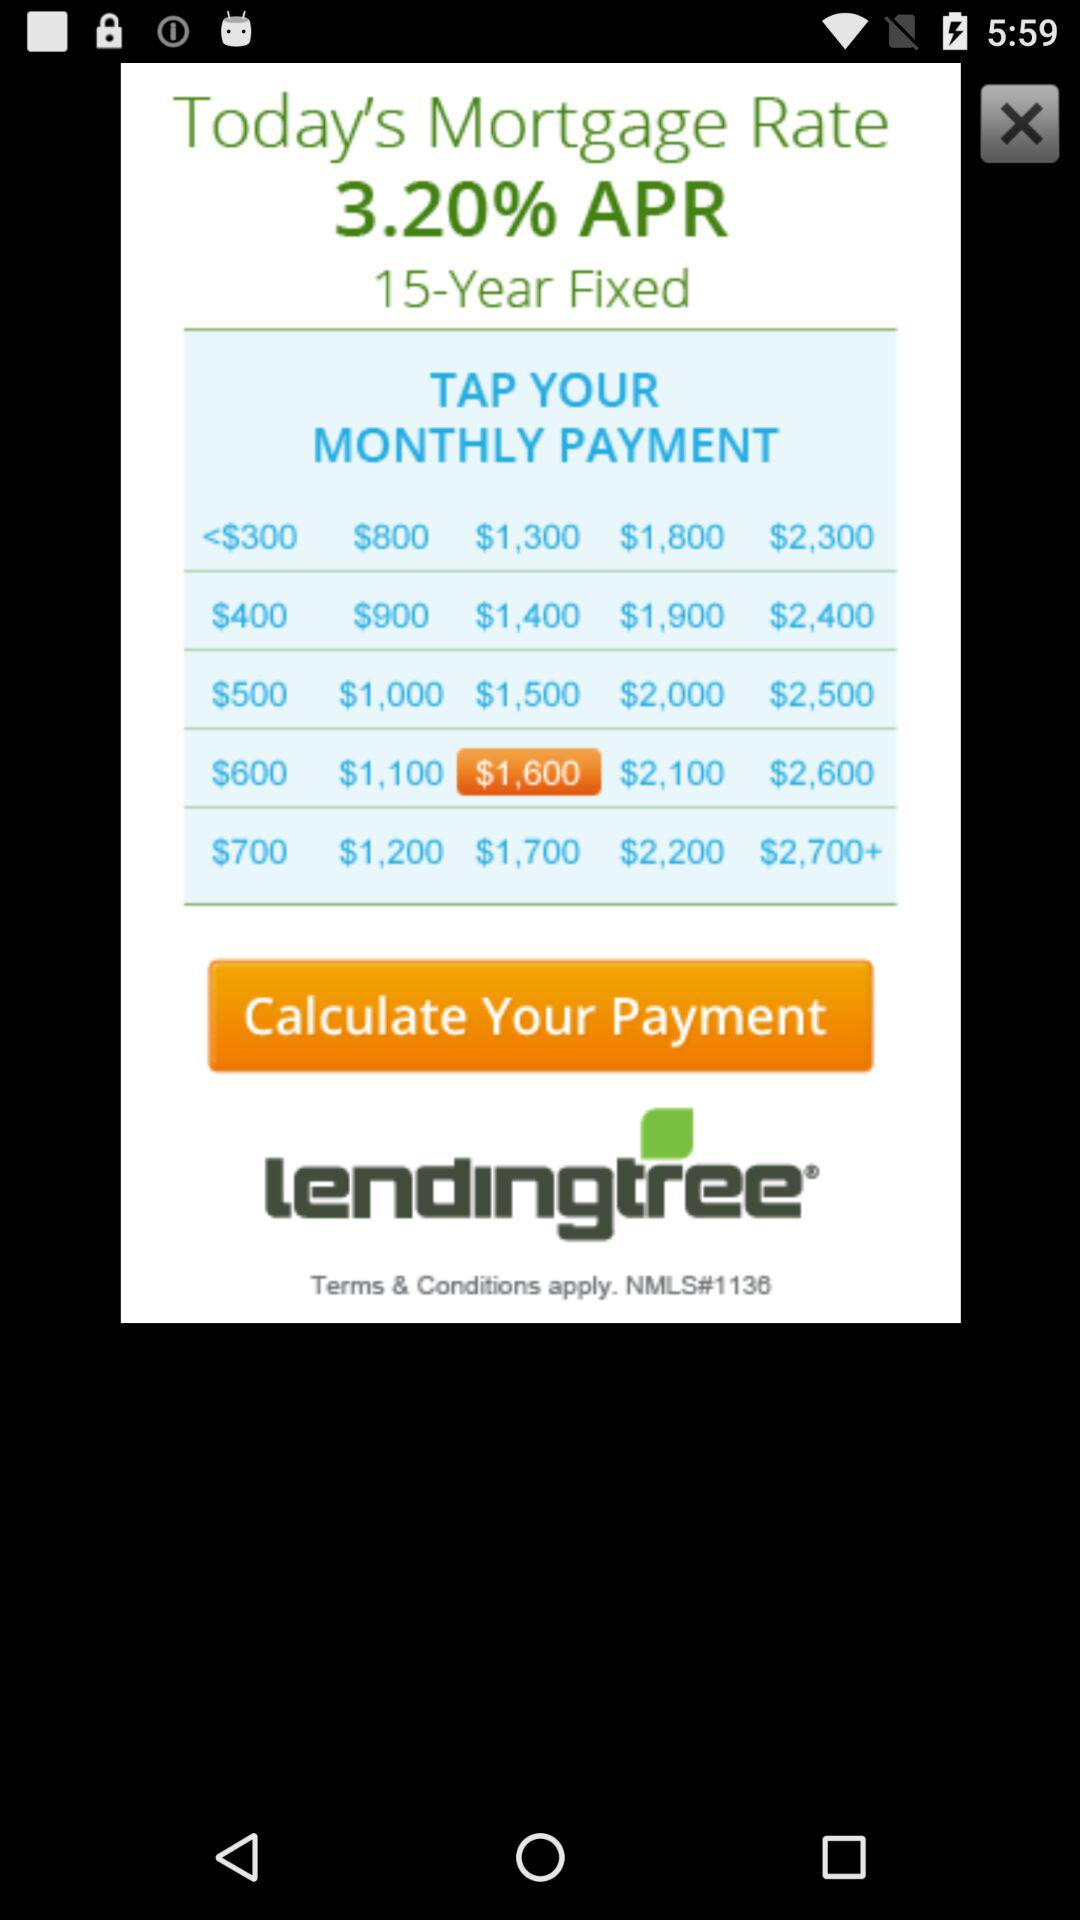How much is today's 30-year fixed mortgage rate?
When the provided information is insufficient, respond with <no answer>. <no answer> 